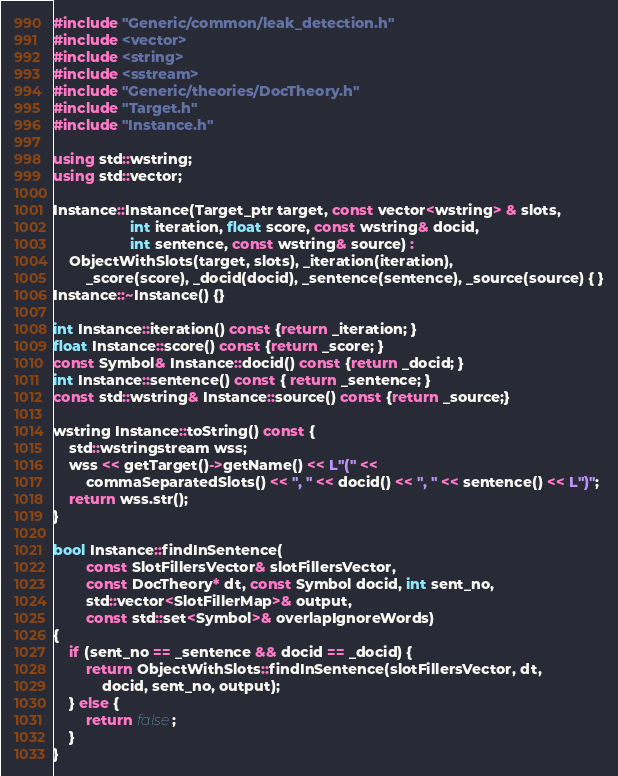Convert code to text. <code><loc_0><loc_0><loc_500><loc_500><_C++_>#include "Generic/common/leak_detection.h"
#include <vector>
#include <string>
#include <sstream>
#include "Generic/theories/DocTheory.h"
#include "Target.h"
#include "Instance.h"

using std::wstring;
using std::vector;

Instance::Instance(Target_ptr target, const vector<wstring> & slots,
				   int iteration, float score, const wstring& docid,
				   int sentence, const wstring& source) :
	ObjectWithSlots(target, slots), _iteration(iteration), 
		_score(score), _docid(docid), _sentence(sentence), _source(source) { }
Instance::~Instance() {}

int Instance::iteration() const {return _iteration; }
float Instance::score() const {return _score; }
const Symbol& Instance::docid() const {return _docid; }
int Instance::sentence() const { return _sentence; }
const std::wstring& Instance::source() const {return _source;}

wstring Instance::toString() const {
	std::wstringstream wss;
	wss << getTarget()->getName() << L"(" << 
		commaSeparatedSlots() << ", " << docid() << ", " << sentence() << L")";
	return wss.str();
}

bool Instance::findInSentence( 
		const SlotFillersVector& slotFillersVector,
		const DocTheory* dt, const Symbol docid, int sent_no,
		std::vector<SlotFillerMap>& output,
        const std::set<Symbol>& overlapIgnoreWords) 
{
	if (sent_no == _sentence && docid == _docid) {
		return ObjectWithSlots::findInSentence(slotFillersVector, dt,
			docid, sent_no, output);
	} else {
		return false;
	}
}

</code> 